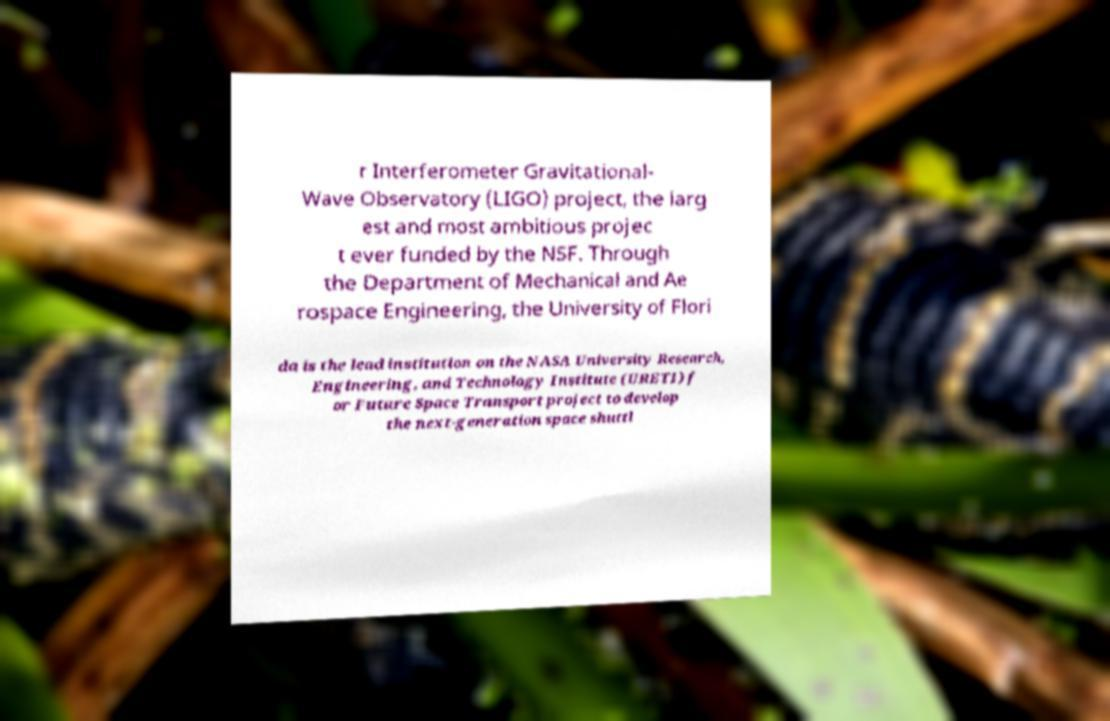Please read and relay the text visible in this image. What does it say? r Interferometer Gravitational- Wave Observatory (LIGO) project, the larg est and most ambitious projec t ever funded by the NSF. Through the Department of Mechanical and Ae rospace Engineering, the University of Flori da is the lead institution on the NASA University Research, Engineering, and Technology Institute (URETI) f or Future Space Transport project to develop the next-generation space shuttl 